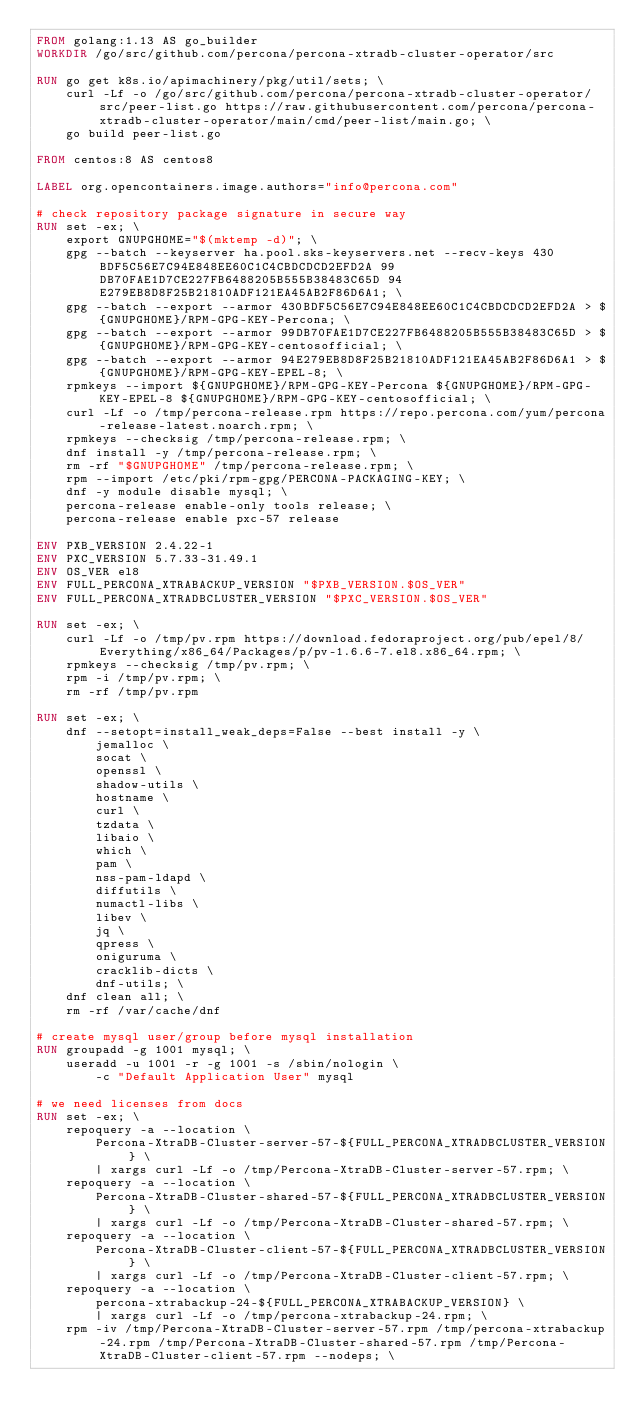<code> <loc_0><loc_0><loc_500><loc_500><_Dockerfile_>FROM golang:1.13 AS go_builder
WORKDIR /go/src/github.com/percona/percona-xtradb-cluster-operator/src

RUN go get k8s.io/apimachinery/pkg/util/sets; \
    curl -Lf -o /go/src/github.com/percona/percona-xtradb-cluster-operator/src/peer-list.go https://raw.githubusercontent.com/percona/percona-xtradb-cluster-operator/main/cmd/peer-list/main.go; \ 
    go build peer-list.go

FROM centos:8 AS centos8

LABEL org.opencontainers.image.authors="info@percona.com"

# check repository package signature in secure way
RUN set -ex; \
	export GNUPGHOME="$(mktemp -d)"; \
	gpg --batch --keyserver ha.pool.sks-keyservers.net --recv-keys 430BDF5C56E7C94E848EE60C1C4CBDCDCD2EFD2A 99DB70FAE1D7CE227FB6488205B555B38483C65D 94E279EB8D8F25B21810ADF121EA45AB2F86D6A1; \
	gpg --batch --export --armor 430BDF5C56E7C94E848EE60C1C4CBDCDCD2EFD2A > ${GNUPGHOME}/RPM-GPG-KEY-Percona; \
	gpg --batch --export --armor 99DB70FAE1D7CE227FB6488205B555B38483C65D > ${GNUPGHOME}/RPM-GPG-KEY-centosofficial; \
	gpg --batch --export --armor 94E279EB8D8F25B21810ADF121EA45AB2F86D6A1 > ${GNUPGHOME}/RPM-GPG-KEY-EPEL-8; \
	rpmkeys --import ${GNUPGHOME}/RPM-GPG-KEY-Percona ${GNUPGHOME}/RPM-GPG-KEY-EPEL-8 ${GNUPGHOME}/RPM-GPG-KEY-centosofficial; \
	curl -Lf -o /tmp/percona-release.rpm https://repo.percona.com/yum/percona-release-latest.noarch.rpm; \
	rpmkeys --checksig /tmp/percona-release.rpm; \
	dnf install -y /tmp/percona-release.rpm; \
	rm -rf "$GNUPGHOME" /tmp/percona-release.rpm; \
	rpm --import /etc/pki/rpm-gpg/PERCONA-PACKAGING-KEY; \
	dnf -y module disable mysql; \
	percona-release enable-only tools release; \
	percona-release enable pxc-57 release

ENV PXB_VERSION 2.4.22-1
ENV PXC_VERSION 5.7.33-31.49.1
ENV OS_VER el8
ENV FULL_PERCONA_XTRABACKUP_VERSION "$PXB_VERSION.$OS_VER"
ENV FULL_PERCONA_XTRADBCLUSTER_VERSION "$PXC_VERSION.$OS_VER"

RUN set -ex; \
	curl -Lf -o /tmp/pv.rpm https://download.fedoraproject.org/pub/epel/8/Everything/x86_64/Packages/p/pv-1.6.6-7.el8.x86_64.rpm; \
	rpmkeys --checksig /tmp/pv.rpm; \
	rpm -i /tmp/pv.rpm; \
	rm -rf /tmp/pv.rpm

RUN set -ex; \
	dnf --setopt=install_weak_deps=False --best install -y \
		jemalloc \
		socat \
		openssl \
		shadow-utils \
		hostname \
		curl \
		tzdata \
		libaio \
		which \
		pam \
		nss-pam-ldapd \
		diffutils \
		numactl-libs \
		libev \
		jq \
		qpress \
		oniguruma \
		cracklib-dicts \
		dnf-utils; \
	dnf clean all; \
	rm -rf /var/cache/dnf

# create mysql user/group before mysql installation
RUN groupadd -g 1001 mysql; \
	useradd -u 1001 -r -g 1001 -s /sbin/nologin \
		-c "Default Application User" mysql

# we need licenses from docs
RUN set -ex; \
	repoquery -a --location \
		Percona-XtraDB-Cluster-server-57-${FULL_PERCONA_XTRADBCLUSTER_VERSION} \
		| xargs curl -Lf -o /tmp/Percona-XtraDB-Cluster-server-57.rpm; \
	repoquery -a --location \
		Percona-XtraDB-Cluster-shared-57-${FULL_PERCONA_XTRADBCLUSTER_VERSION} \
		| xargs curl -Lf -o /tmp/Percona-XtraDB-Cluster-shared-57.rpm; \
	repoquery -a --location \
		Percona-XtraDB-Cluster-client-57-${FULL_PERCONA_XTRADBCLUSTER_VERSION} \
		| xargs curl -Lf -o /tmp/Percona-XtraDB-Cluster-client-57.rpm; \
	repoquery -a --location \
		percona-xtrabackup-24-${FULL_PERCONA_XTRABACKUP_VERSION} \
		| xargs curl -Lf -o /tmp/percona-xtrabackup-24.rpm; \
	rpm -iv /tmp/Percona-XtraDB-Cluster-server-57.rpm /tmp/percona-xtrabackup-24.rpm /tmp/Percona-XtraDB-Cluster-shared-57.rpm /tmp/Percona-XtraDB-Cluster-client-57.rpm --nodeps; \</code> 